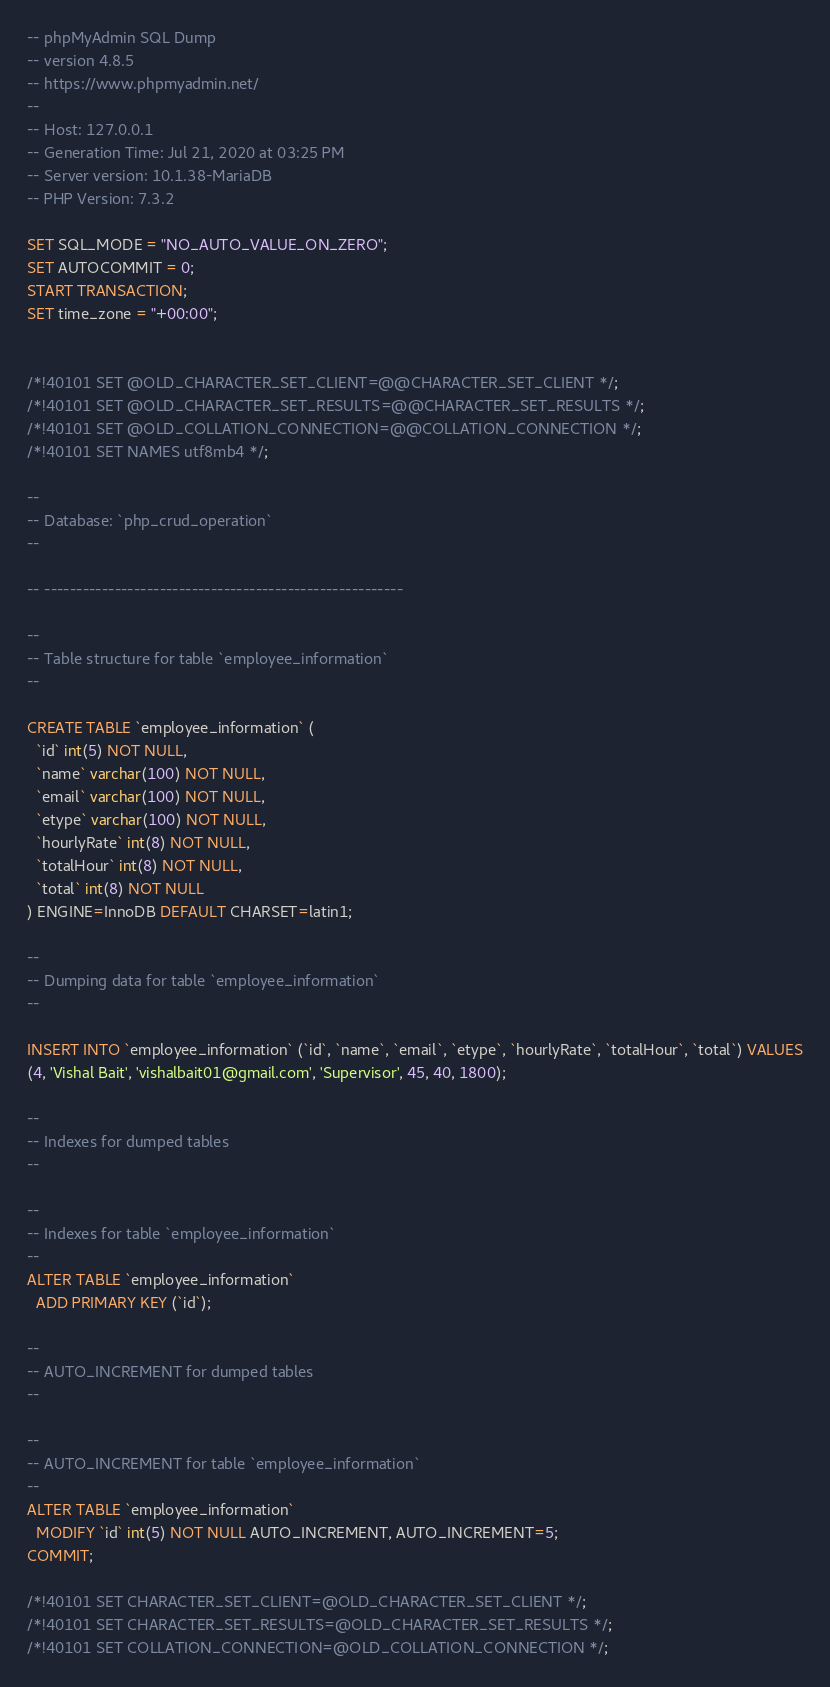Convert code to text. <code><loc_0><loc_0><loc_500><loc_500><_SQL_>-- phpMyAdmin SQL Dump
-- version 4.8.5
-- https://www.phpmyadmin.net/
--
-- Host: 127.0.0.1
-- Generation Time: Jul 21, 2020 at 03:25 PM
-- Server version: 10.1.38-MariaDB
-- PHP Version: 7.3.2

SET SQL_MODE = "NO_AUTO_VALUE_ON_ZERO";
SET AUTOCOMMIT = 0;
START TRANSACTION;
SET time_zone = "+00:00";


/*!40101 SET @OLD_CHARACTER_SET_CLIENT=@@CHARACTER_SET_CLIENT */;
/*!40101 SET @OLD_CHARACTER_SET_RESULTS=@@CHARACTER_SET_RESULTS */;
/*!40101 SET @OLD_COLLATION_CONNECTION=@@COLLATION_CONNECTION */;
/*!40101 SET NAMES utf8mb4 */;

--
-- Database: `php_crud_operation`
--

-- --------------------------------------------------------

--
-- Table structure for table `employee_information`
--

CREATE TABLE `employee_information` (
  `id` int(5) NOT NULL,
  `name` varchar(100) NOT NULL,
  `email` varchar(100) NOT NULL,
  `etype` varchar(100) NOT NULL,
  `hourlyRate` int(8) NOT NULL,
  `totalHour` int(8) NOT NULL,
  `total` int(8) NOT NULL
) ENGINE=InnoDB DEFAULT CHARSET=latin1;

--
-- Dumping data for table `employee_information`
--

INSERT INTO `employee_information` (`id`, `name`, `email`, `etype`, `hourlyRate`, `totalHour`, `total`) VALUES
(4, 'Vishal Bait', 'vishalbait01@gmail.com', 'Supervisor', 45, 40, 1800);

--
-- Indexes for dumped tables
--

--
-- Indexes for table `employee_information`
--
ALTER TABLE `employee_information`
  ADD PRIMARY KEY (`id`);

--
-- AUTO_INCREMENT for dumped tables
--

--
-- AUTO_INCREMENT for table `employee_information`
--
ALTER TABLE `employee_information`
  MODIFY `id` int(5) NOT NULL AUTO_INCREMENT, AUTO_INCREMENT=5;
COMMIT;

/*!40101 SET CHARACTER_SET_CLIENT=@OLD_CHARACTER_SET_CLIENT */;
/*!40101 SET CHARACTER_SET_RESULTS=@OLD_CHARACTER_SET_RESULTS */;
/*!40101 SET COLLATION_CONNECTION=@OLD_COLLATION_CONNECTION */;
</code> 